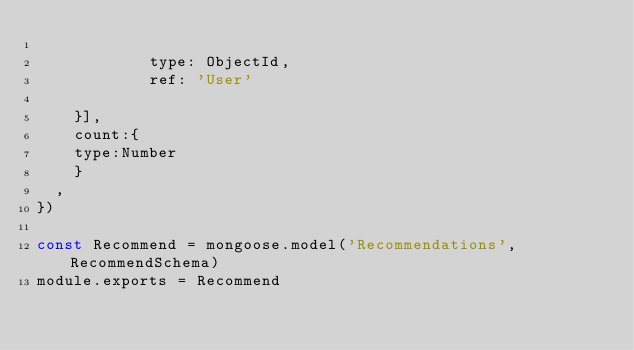Convert code to text. <code><loc_0><loc_0><loc_500><loc_500><_JavaScript_>       
            type: ObjectId,
            ref: 'User'
        
    }],
    count:{
    type:Number
    }
  ,
})

const Recommend = mongoose.model('Recommendations', RecommendSchema)
module.exports = Recommend</code> 